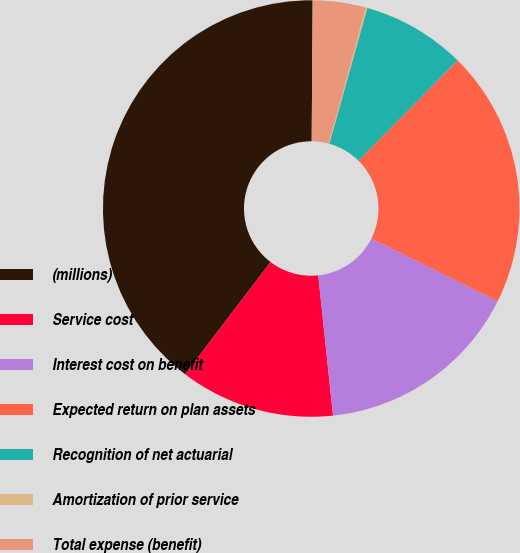Convert chart to OTSL. <chart><loc_0><loc_0><loc_500><loc_500><pie_chart><fcel>(millions)<fcel>Service cost<fcel>Interest cost on benefit<fcel>Expected return on plan assets<fcel>Recognition of net actuarial<fcel>Amortization of prior service<fcel>Total expense (benefit)<nl><fcel>39.76%<fcel>12.02%<fcel>15.98%<fcel>19.95%<fcel>8.06%<fcel>0.13%<fcel>4.1%<nl></chart> 